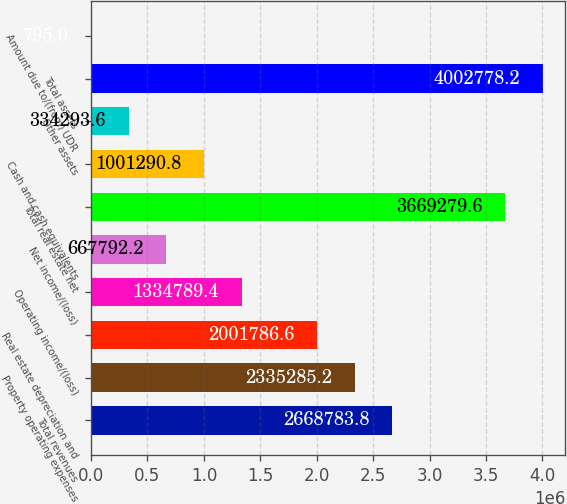Convert chart. <chart><loc_0><loc_0><loc_500><loc_500><bar_chart><fcel>Total revenues<fcel>Property operating expenses<fcel>Real estate depreciation and<fcel>Operating income/(loss)<fcel>Net income/(loss)<fcel>Total real estate net<fcel>Cash and cash equivalents<fcel>Other assets<fcel>Total assets<fcel>Amount due to/(from) UDR<nl><fcel>2.66878e+06<fcel>2.33529e+06<fcel>2.00179e+06<fcel>1.33479e+06<fcel>667792<fcel>3.66928e+06<fcel>1.00129e+06<fcel>334294<fcel>4.00278e+06<fcel>795<nl></chart> 